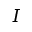<formula> <loc_0><loc_0><loc_500><loc_500>I</formula> 